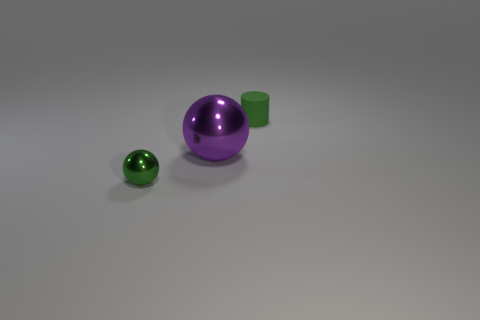The other tiny object that is the same color as the tiny rubber object is what shape? sphere 